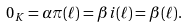Convert formula to latex. <formula><loc_0><loc_0><loc_500><loc_500>0 _ { K } = \alpha \pi ( \ell ) = \beta i ( \ell ) = \beta ( \ell ) .</formula> 